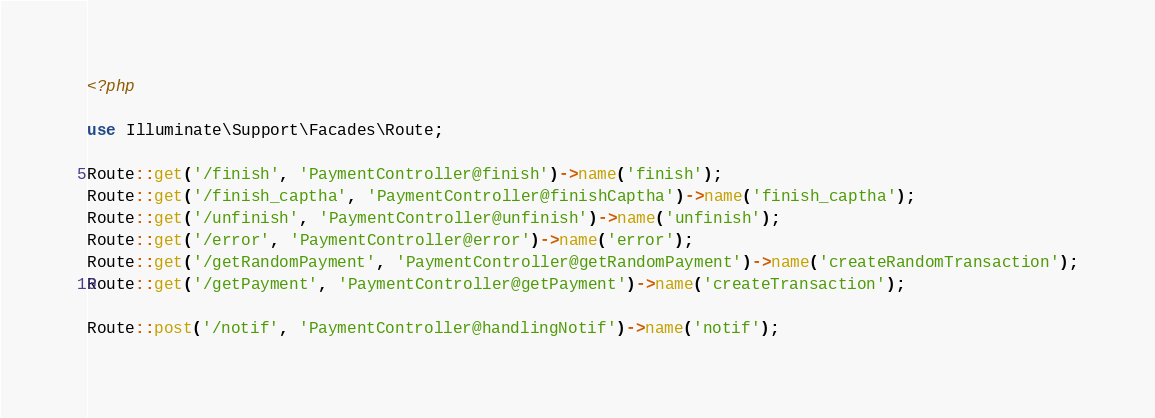<code> <loc_0><loc_0><loc_500><loc_500><_PHP_><?php

use Illuminate\Support\Facades\Route;

Route::get('/finish', 'PaymentController@finish')->name('finish');
Route::get('/finish_captha', 'PaymentController@finishCaptha')->name('finish_captha');
Route::get('/unfinish', 'PaymentController@unfinish')->name('unfinish');
Route::get('/error', 'PaymentController@error')->name('error');
Route::get('/getRandomPayment', 'PaymentController@getRandomPayment')->name('createRandomTransaction');
Route::get('/getPayment', 'PaymentController@getPayment')->name('createTransaction');

Route::post('/notif', 'PaymentController@handlingNotif')->name('notif');
</code> 